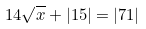<formula> <loc_0><loc_0><loc_500><loc_500>1 4 \sqrt { x } + | 1 5 | = | 7 1 |</formula> 